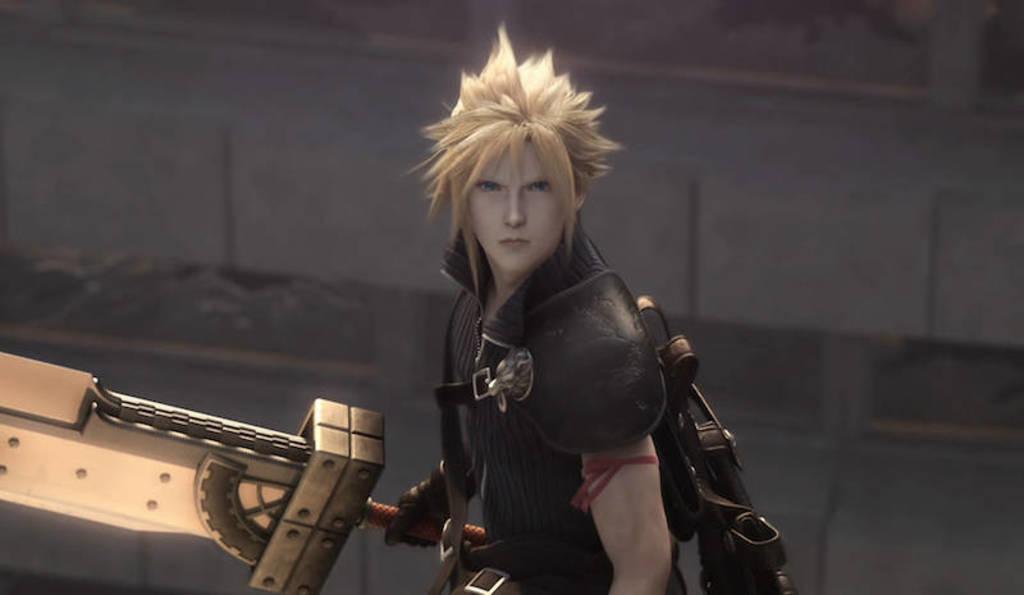How would you summarize this image in a sentence or two? This picture seems to be an animated image. In the center there is a person wearing black color dress and holding an object and wearing a backpack. In the background there is a wall. 